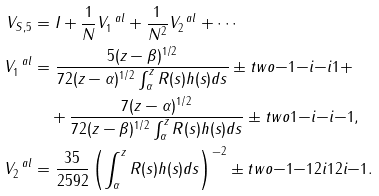<formula> <loc_0><loc_0><loc_500><loc_500>V _ { S , 5 } & = I + \frac { 1 } { N } V ^ { \ a l } _ { 1 } + \frac { 1 } { N ^ { 2 } } V ^ { \ a l } _ { 2 } + \cdots \\ V _ { 1 } ^ { \ a l } & = \frac { 5 ( z - \beta ) ^ { 1 / 2 } } { 7 2 ( z - \alpha ) ^ { 1 / 2 } \int _ { \alpha } ^ { z } R ( s ) h ( s ) d s } \pm t w o { - 1 } { - i } { - i } { 1 } + \\ & \quad + \frac { 7 ( z - \alpha ) ^ { 1 / 2 } } { 7 2 ( z - \beta ) ^ { 1 / 2 } \int _ { \alpha } ^ { z } R ( s ) h ( s ) d s } \pm t w o { 1 } { - i } { - i } { - 1 } , \\ V _ { 2 } ^ { \ a l } & = \frac { 3 5 } { 2 5 9 2 } \left ( \int _ { \alpha } ^ { z } R ( s ) h ( s ) d s \right ) ^ { - 2 } \pm t w o { - 1 } { - 1 2 i } { 1 2 i } { - 1 } .</formula> 